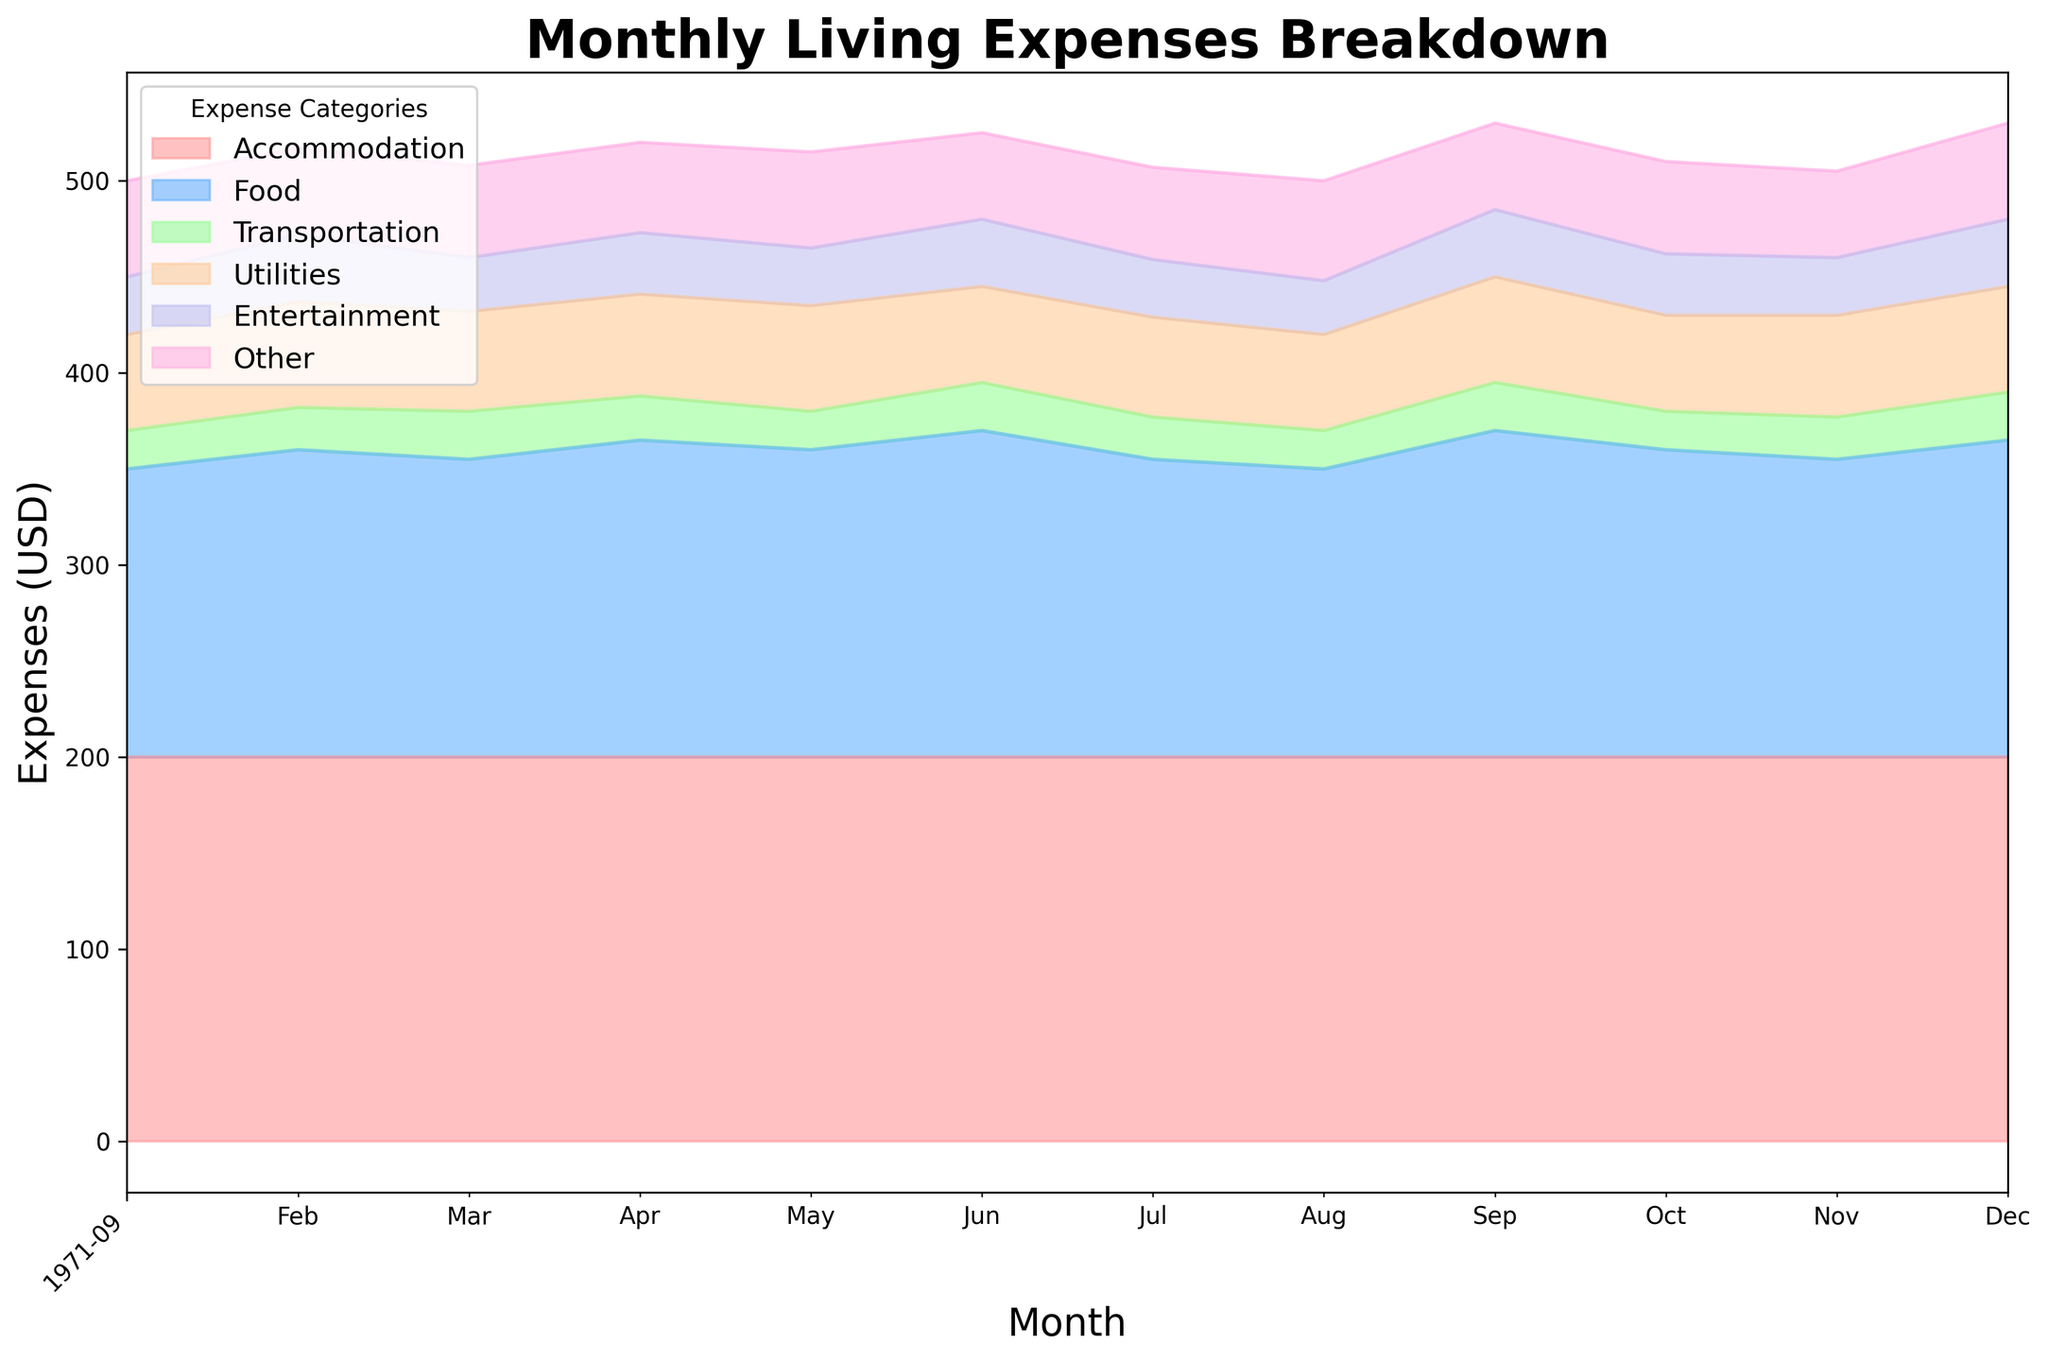Which month had the lowest total living expenses? First, observe the area chart to identify the month where the sum of all stacked layers reaches the lowest point.
Answer: August 2023 In which month was the expense on utilities the highest? Look at the Utilities layer and find the peak height. Check the corresponding month on the x-axis.
Answer: February 2023 and December 2023 How did the food expenses change from January to June? Compare the height of the Food layer in January to its height in June. Note the change in value.
Answer: Increased by 20 USD Which month had the highest expenses in the Entertainment category? Look at the Entertainment layer and find the peak height. Check the corresponding month on the x-axis.
Answer: June 2023 How do accommodation expenses compare to other categories over the year? Observe the Accommodation layer (a consistent color) and note its stability and height compared to other fluctuating layers.
Answer: Accommodation expenses are consistently higher and stable Which category shows the most fluctuation over the year? Examine the chart for the layer with the most noticeable ups and downs.
Answer: Entertainment What is the total expense in the month with the highest utilities expense? Find when the Utilities expense was highest, sum all expenses for that month. Highest Utilities: February (55 USD). Total: 200 + 160 + 22 + 55 + 35 + 45 = 517 USD
Answer: 517 USD By how much did the Transportation expenses decrease from September to November? Note the Transportation expenses in September and November and subtract the latter from the former: 25 USD (September) - 22 USD (November) = 3 USD
Answer: 3 USD What's the cumulative sum of 'Other' expenses in the first quarter of the year? Sum 'Other' expenses for January, February, and March: 50 + 45 + 48 = 143 USD
Answer: 143 USD 